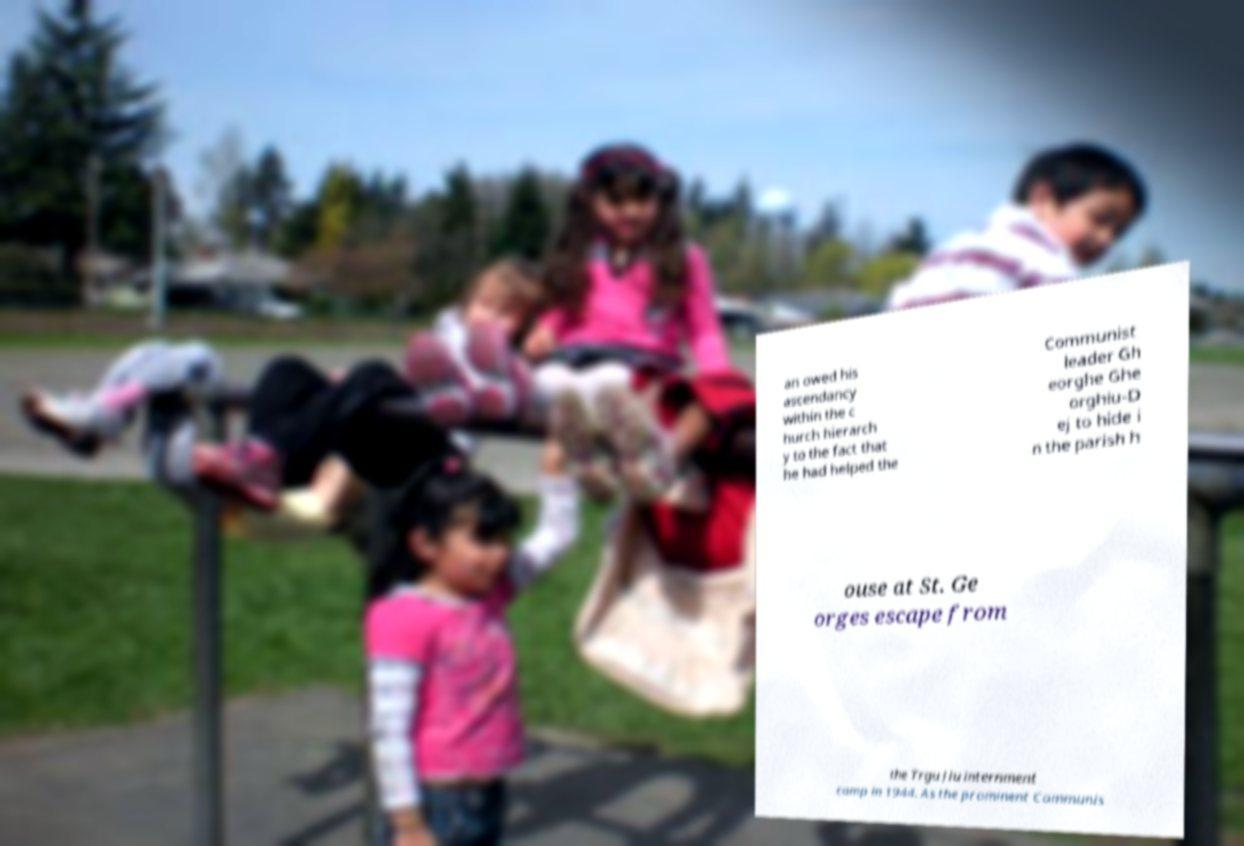What messages or text are displayed in this image? I need them in a readable, typed format. an owed his ascendancy within the c hurch hierarch y to the fact that he had helped the Communist leader Gh eorghe Ghe orghiu-D ej to hide i n the parish h ouse at St. Ge orges escape from the Trgu Jiu internment camp in 1944. As the prominent Communis 